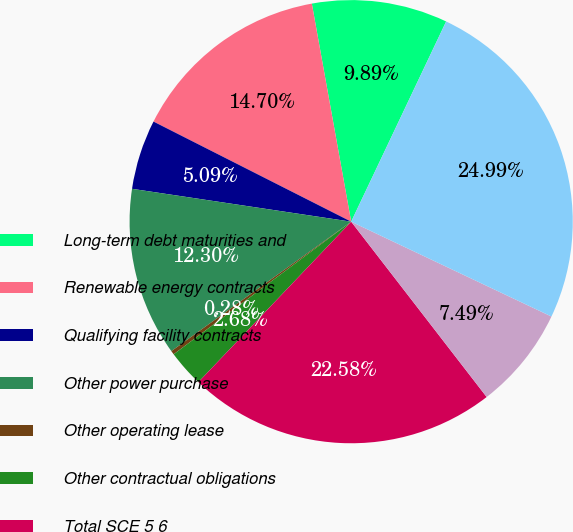Convert chart to OTSL. <chart><loc_0><loc_0><loc_500><loc_500><pie_chart><fcel>Long-term debt maturities and<fcel>Renewable energy contracts<fcel>Qualifying facility contracts<fcel>Other power purchase<fcel>Other operating lease<fcel>Other contractual obligations<fcel>Total SCE 5 6<fcel>Total Edison International<fcel>Total Edison International 67<nl><fcel>9.89%<fcel>14.7%<fcel>5.09%<fcel>12.3%<fcel>0.28%<fcel>2.68%<fcel>22.58%<fcel>7.49%<fcel>24.99%<nl></chart> 